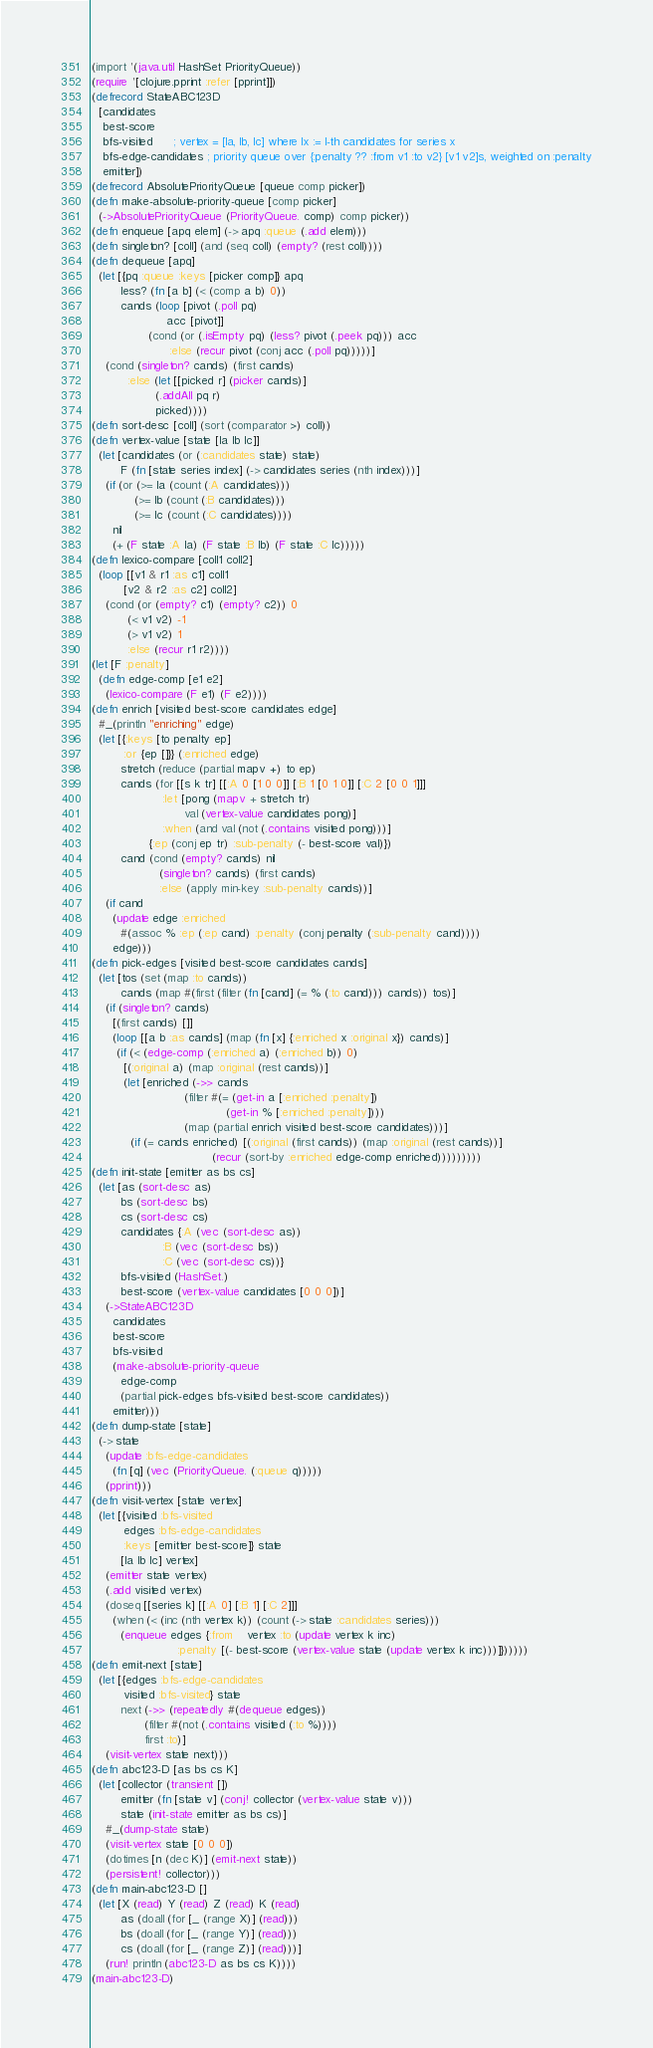Convert code to text. <code><loc_0><loc_0><loc_500><loc_500><_Clojure_>(import '(java.util HashSet PriorityQueue))
(require '[clojure.pprint :refer [pprint]])
(defrecord StateABC123D
  [candidates
   best-score
   bfs-visited      ; vertex = [Ia, Ib, Ic] where Ix := I-th candidates for series x
   bfs-edge-candidates ; priority queue over {:penalty ?? :from v1 :to v2} [v1 v2]s, weighted on :penalty
   emitter])
(defrecord AbsolutePriorityQueue [queue comp picker])
(defn make-absolute-priority-queue [comp picker]
  (->AbsolutePriorityQueue (PriorityQueue. comp) comp picker))
(defn enqueue [apq elem] (-> apq :queue (.add elem)))
(defn singleton? [coll] (and (seq coll) (empty? (rest coll))))
(defn dequeue [apq]
  (let [{pq :queue :keys [picker comp]} apq
        less? (fn [a b] (< (comp a b) 0))
        cands (loop [pivot (.poll pq)
                     acc [pivot]]
                (cond (or (.isEmpty pq) (less? pivot (.peek pq))) acc
                      :else (recur pivot (conj acc (.poll pq)))))]
    (cond (singleton? cands) (first cands)
          :else (let [[picked r] (picker cands)]
                  (.addAll pq r)
                  picked))))
(defn sort-desc [coll] (sort (comparator >) coll))
(defn vertex-value [state [Ia Ib Ic]]
  (let [candidates (or (:candidates state) state)
        F (fn [state series index] (-> candidates series (nth index)))]
    (if (or (>= Ia (count (:A candidates)))
            (>= Ib (count (:B candidates)))
            (>= Ic (count (:C candidates))))
      nil
      (+ (F state :A Ia) (F state :B Ib) (F state :C Ic)))))
(defn lexico-compare [coll1 coll2]
  (loop [[v1 & r1 :as c1] coll1
         [v2 & r2 :as c2] coll2]
    (cond (or (empty? c1) (empty? c2)) 0
          (< v1 v2) -1
          (> v1 v2) 1
          :else (recur r1 r2))))
(let [F :penalty]
  (defn edge-comp [e1 e2]
    (lexico-compare (F e1) (F e2))))
(defn enrich [visited best-score candidates edge]
  #_(println "enriching" edge)
  (let [{:keys [to penalty ep]
         :or {ep []}} (:enriched edge)
        stretch (reduce (partial mapv +) to ep)
        cands (for [[s k tr] [[:A 0 [1 0 0]] [:B 1 [0 1 0]] [:C 2 [0 0 1]]]
                    :let [pong (mapv + stretch tr)
                          val (vertex-value candidates pong)]
                    :when (and val (not (.contains visited pong)))]
                {:ep (conj ep tr) :sub-penalty (- best-score val)})
        cand (cond (empty? cands) nil
                   (singleton? cands) (first cands)
                   :else (apply min-key :sub-penalty cands))]
    (if cand
      (update edge :enriched
        #(assoc % :ep (:ep cand) :penalty (conj penalty (:sub-penalty cand))))
      edge)))
(defn pick-edges [visited best-score candidates cands]
  (let [tos (set (map :to cands))
        cands (map #(first (filter (fn [cand] (= % (:to cand))) cands)) tos)]
    (if (singleton? cands)
      [(first cands) []]
      (loop [[a b :as cands] (map (fn [x] {:enriched x :original x}) cands)]
       (if (< (edge-comp (:enriched a) (:enriched b)) 0)
         [(:original a) (map :original (rest cands))]
         (let [enriched (->> cands
                          (filter #(= (get-in a [:enriched :penalty])
                                      (get-in % [:enriched :penalty])))
                          (map (partial enrich visited best-score candidates)))]
           (if (= cands enriched) [(:original (first cands)) (map :original (rest cands))]
                                  (recur (sort-by :enriched edge-comp enriched)))))))))
(defn init-state [emitter as bs cs]
  (let [as (sort-desc as)
        bs (sort-desc bs)
        cs (sort-desc cs)
        candidates {:A (vec (sort-desc as))
                    :B (vec (sort-desc bs))
                    :C (vec (sort-desc cs))}
        bfs-visited (HashSet.)
        best-score (vertex-value candidates [0 0 0])]
    (->StateABC123D
      candidates
      best-score
      bfs-visited
      (make-absolute-priority-queue
        edge-comp
        (partial pick-edges bfs-visited best-score candidates))
      emitter)))
(defn dump-state [state]
  (-> state
    (update :bfs-edge-candidates
      (fn [q] (vec (PriorityQueue. (:queue q)))))
    (pprint)))
(defn visit-vertex [state vertex]
  (let [{visited :bfs-visited
         edges :bfs-edge-candidates
         :keys [emitter best-score]} state
        [Ia Ib Ic] vertex]
    (emitter state vertex)
    (.add visited vertex)
    (doseq [[series k] [[:A 0] [:B 1] [:C 2]]]
      (when (< (inc (nth vertex k)) (count (-> state :candidates series)))
        (enqueue edges {:from    vertex :to (update vertex k inc)
                        :penalty [(- best-score (vertex-value state (update vertex k inc)))]})))))
(defn emit-next [state]
  (let [{edges :bfs-edge-candidates
         visited :bfs-visited} state
        next (->> (repeatedly #(dequeue edges))
               (filter #(not (.contains visited (:to %))))
               first :to)]
    (visit-vertex state next)))
(defn abc123-D [as bs cs K]
  (let [collector (transient [])
        emitter (fn [state v] (conj! collector (vertex-value state v)))
        state (init-state emitter as bs cs)]
    #_(dump-state state)
    (visit-vertex state [0 0 0])
    (dotimes [n (dec K)] (emit-next state))
    (persistent! collector)))
(defn main-abc123-D []
  (let [X (read) Y (read) Z (read) K (read)
        as (doall (for [_ (range X)] (read)))
        bs (doall (for [_ (range Y)] (read)))
        cs (doall (for [_ (range Z)] (read)))]
    (run! println (abc123-D as bs cs K))))
(main-abc123-D)</code> 